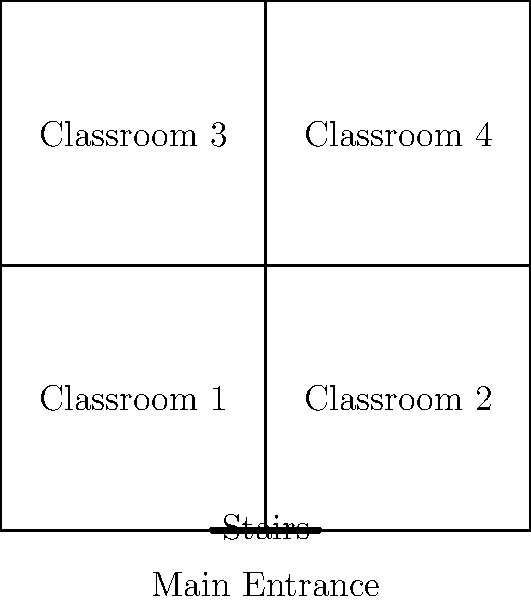Based on the architectural drawing of a school building, which accessibility feature is most crucial for ensuring equal access to all classrooms for students with mobility impairments? To analyze the accessibility of this school building layout for students with mobility impairments, we need to consider the following steps:

1. Identify the building's layout: The school has four classrooms arranged in a square formation with corridors running between them.

2. Locate the main entrance: The main entrance is at the bottom of the diagram.

3. Identify vertical circulation methods:
   a. Stairs: Located near the main entrance
   b. Ramp: Located on the right side of the building
   c. Elevator: Located on the left side of the building

4. Analyze accessibility to each classroom:
   - Classroom 1 and 2 (ground floor): Accessible via the main entrance
   - Classroom 3 and 4 (upper floor): Require vertical circulation

5. Evaluate the importance of each accessibility feature:
   - Stairs: Not suitable for students with mobility impairments
   - Ramp: Provides access to the upper floor but may be challenging for some students
   - Elevator: Offers the most convenient and universally accessible option for reaching the upper floor

6. Consider the principles of universal design:
   The elevator provides the most inclusive solution, accommodating students with various mobility needs without requiring additional effort or assistance.

Based on this analysis, the elevator is the most crucial accessibility feature for ensuring equal access to all classrooms for students with mobility impairments. It allows independent and effortless vertical circulation between floors, making all classrooms equally accessible.
Answer: Elevator 